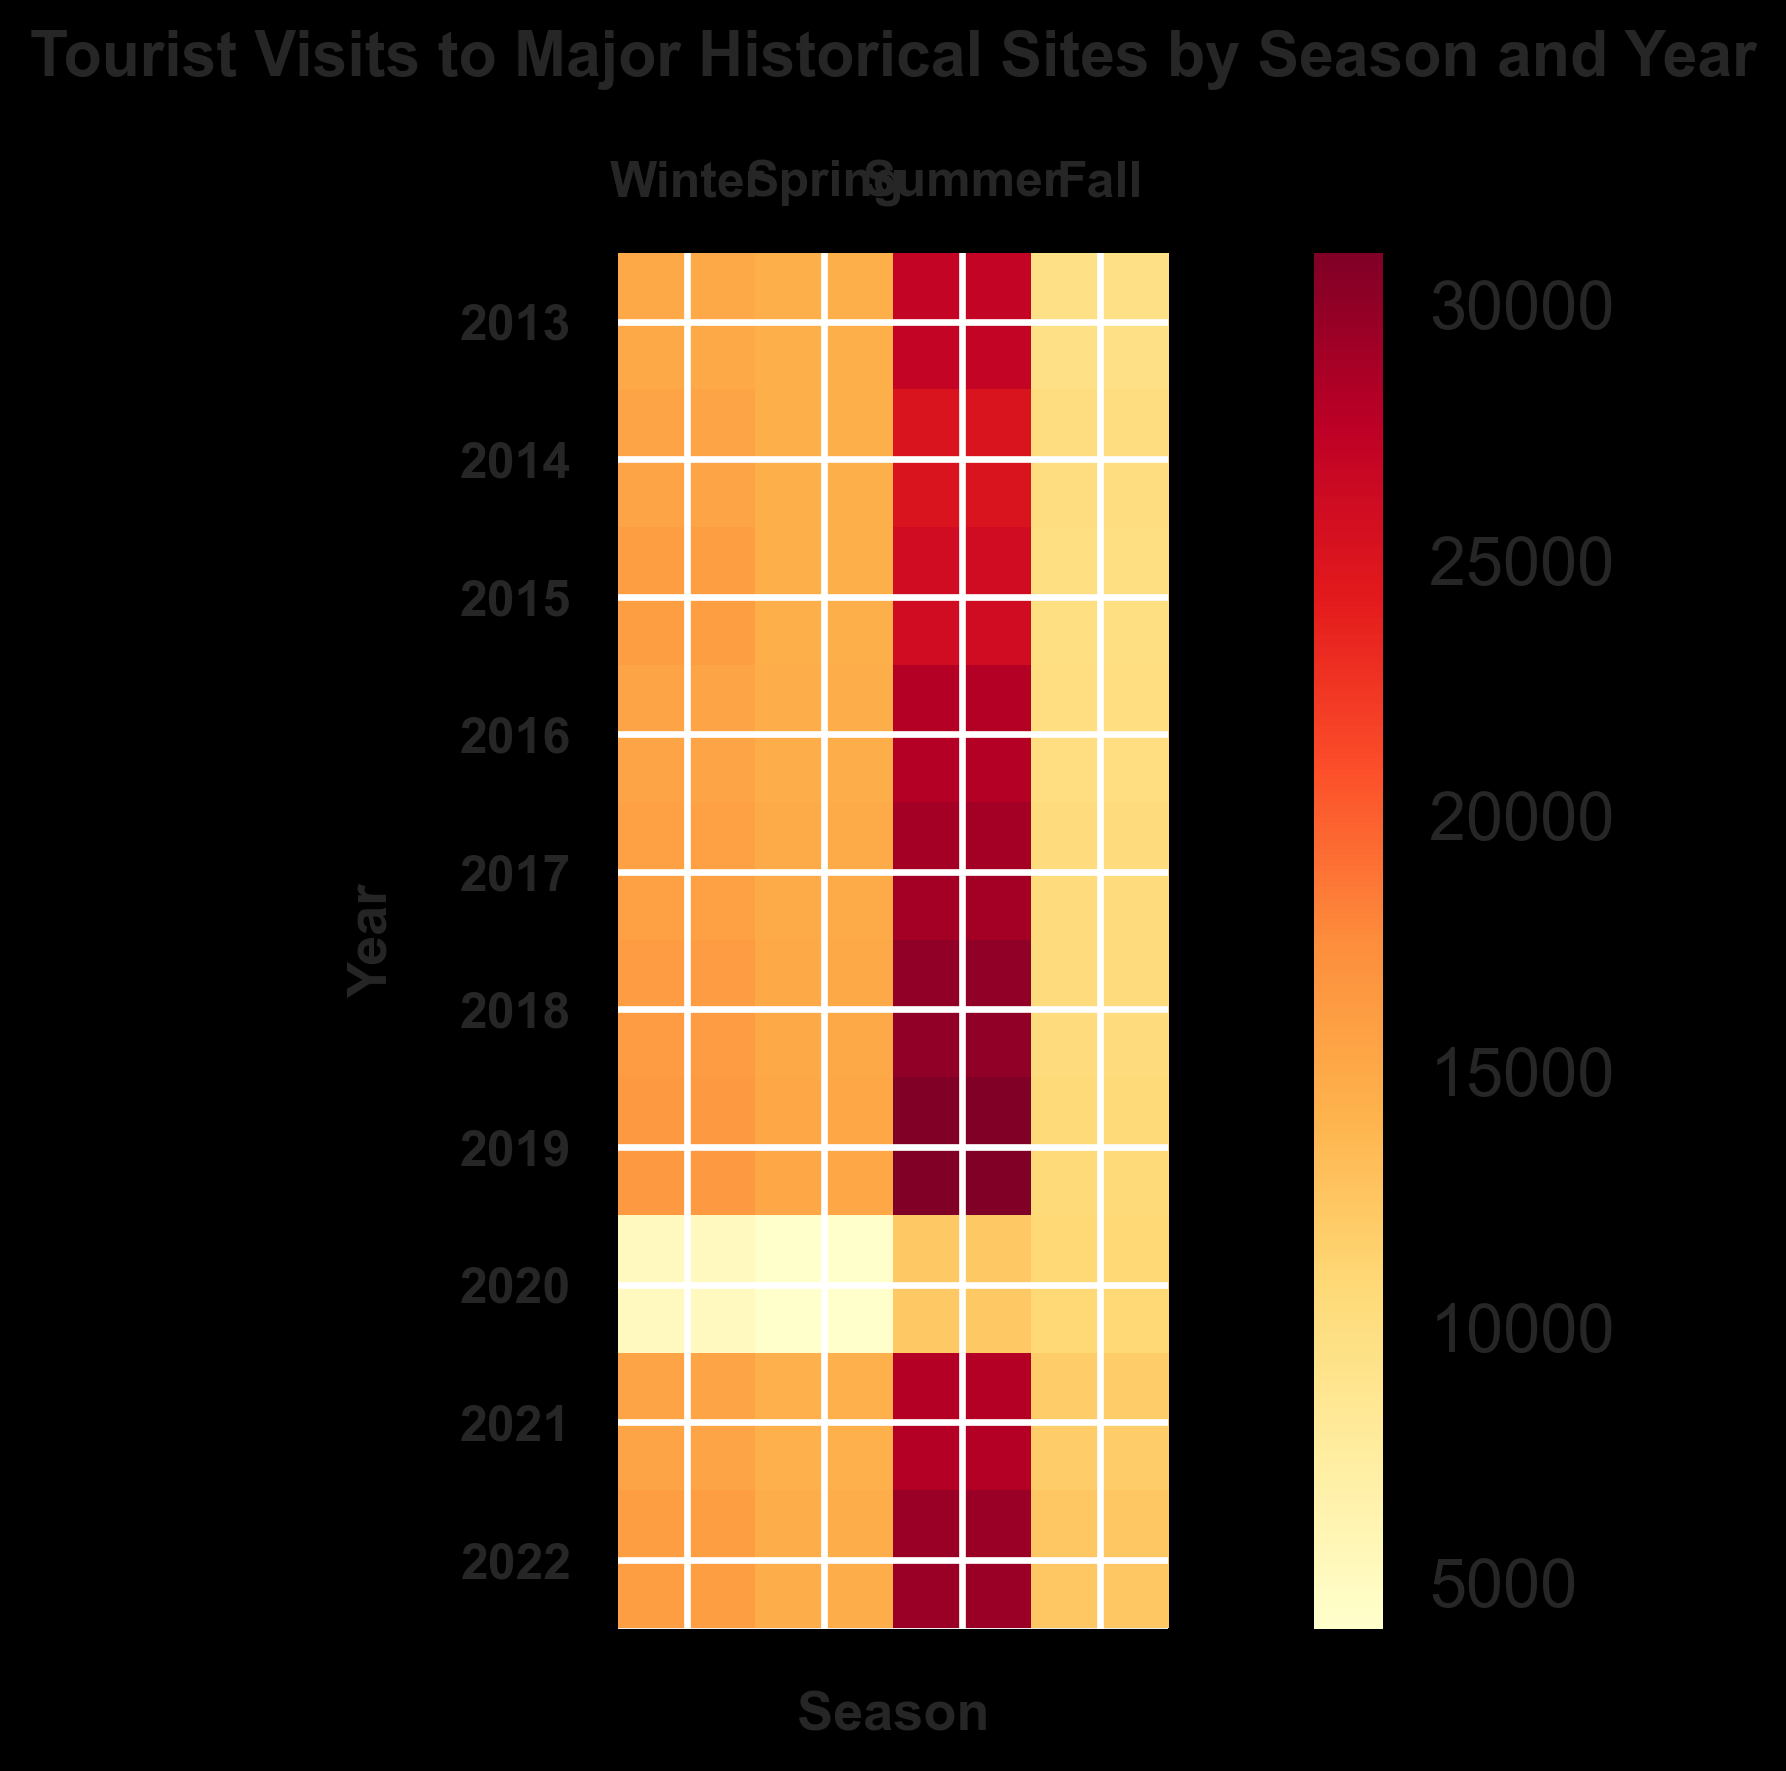What year had the lowest tourist visits during Spring? To find the year with the lowest tourist visits in Spring, locate the Spring column and identify the year with the least intense color. Look for the lowest numerical value in that column.
Answer: 2020 Which season had the highest tourist visits in 2018? Locate the row corresponding to 2018 and identify the season with the most intense color, which indicates the highest number of visits.
Answer: Summer How did the tourist visits in Summer 2020 compare to Summer 2019? First, locate the Summer column and find the respective rows for 2020 and 2019. Compare the colors and values to see which is higher.
Answer: Lower in 2020 What was the trend of tourist visits in Winter from 2013 to 2022? Look at the Winter column and observe the changes in color intensity from 2013 to 2022. Determine if the trend shows an increasing, decreasing, or fluctuating pattern.
Answer: Generally increasing Which season shows the most fluctuation in tourist visits over the years? Compare the columns for Winter, Spring, Summer, and Fall. Look for the column with the most varied colors, indicating significant changes in visits from year to year.
Answer: Spring What season in 2020 had the smallest number of tourist visits? Find the row for 2020 and identify the season with the least intense color, indicating the fewest visits.
Answer: Spring How did tourist visits change from Winter to Fall in 2021? Locate the row for 2021 and compare the colors and values from Winter to Fall to determine the trend.
Answer: Increased What is the average number of tourist visits in Summer from 2013 to 2022 for SiteA? Sum the number of visits for SiteA in Summer across all years (2013-2022) and divide by the number of years.
Answer: 15150 Between SiteA and SiteB, which had more visits in Fall 2019? Locate the Fall 2019 column and rows for SiteA and SiteB. Compare the numerical values to see which is higher.
Answer: SiteA How did the tourist visits in Fall 2020 compare to other years? Locate the Fall column and row for 2020. Compare the coloring and values with the Fall data of other years to determine the difference.
Answer: Significantly lower 